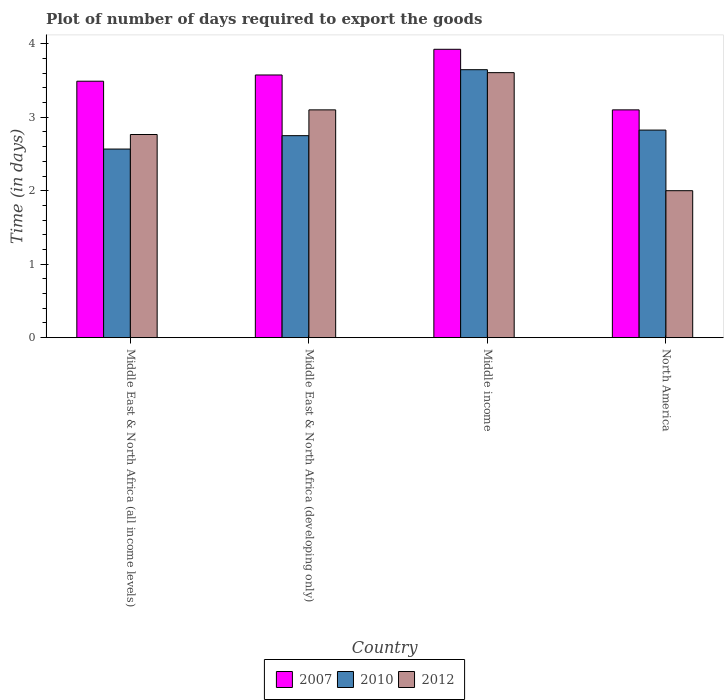Are the number of bars per tick equal to the number of legend labels?
Ensure brevity in your answer.  Yes. Are the number of bars on each tick of the X-axis equal?
Make the answer very short. Yes. How many bars are there on the 1st tick from the left?
Offer a terse response. 3. How many bars are there on the 2nd tick from the right?
Give a very brief answer. 3. What is the label of the 1st group of bars from the left?
Offer a terse response. Middle East & North Africa (all income levels). What is the time required to export goods in 2010 in Middle East & North Africa (all income levels)?
Your answer should be compact. 2.57. Across all countries, what is the maximum time required to export goods in 2012?
Offer a terse response. 3.61. Across all countries, what is the minimum time required to export goods in 2010?
Your response must be concise. 2.57. In which country was the time required to export goods in 2010 minimum?
Your response must be concise. Middle East & North Africa (all income levels). What is the total time required to export goods in 2012 in the graph?
Give a very brief answer. 11.47. What is the difference between the time required to export goods in 2012 in Middle East & North Africa (all income levels) and that in North America?
Your response must be concise. 0.76. What is the difference between the time required to export goods in 2012 in North America and the time required to export goods in 2007 in Middle East & North Africa (developing only)?
Make the answer very short. -1.58. What is the average time required to export goods in 2010 per country?
Your answer should be very brief. 2.95. What is the difference between the time required to export goods of/in 2007 and time required to export goods of/in 2012 in Middle East & North Africa (all income levels)?
Keep it short and to the point. 0.73. What is the ratio of the time required to export goods in 2007 in Middle East & North Africa (developing only) to that in Middle income?
Give a very brief answer. 0.91. Is the time required to export goods in 2010 in Middle income less than that in North America?
Provide a succinct answer. No. What is the difference between the highest and the second highest time required to export goods in 2007?
Provide a short and direct response. -0.35. What is the difference between the highest and the lowest time required to export goods in 2012?
Your answer should be very brief. 1.61. Is it the case that in every country, the sum of the time required to export goods in 2007 and time required to export goods in 2010 is greater than the time required to export goods in 2012?
Offer a terse response. Yes. How many bars are there?
Offer a very short reply. 12. What is the difference between two consecutive major ticks on the Y-axis?
Provide a short and direct response. 1. Does the graph contain grids?
Make the answer very short. No. What is the title of the graph?
Give a very brief answer. Plot of number of days required to export the goods. What is the label or title of the X-axis?
Make the answer very short. Country. What is the label or title of the Y-axis?
Offer a very short reply. Time (in days). What is the Time (in days) in 2007 in Middle East & North Africa (all income levels)?
Give a very brief answer. 3.49. What is the Time (in days) in 2010 in Middle East & North Africa (all income levels)?
Your response must be concise. 2.57. What is the Time (in days) of 2012 in Middle East & North Africa (all income levels)?
Your answer should be very brief. 2.76. What is the Time (in days) in 2007 in Middle East & North Africa (developing only)?
Give a very brief answer. 3.58. What is the Time (in days) of 2010 in Middle East & North Africa (developing only)?
Give a very brief answer. 2.75. What is the Time (in days) of 2012 in Middle East & North Africa (developing only)?
Offer a very short reply. 3.1. What is the Time (in days) in 2007 in Middle income?
Offer a very short reply. 3.92. What is the Time (in days) of 2010 in Middle income?
Make the answer very short. 3.65. What is the Time (in days) in 2012 in Middle income?
Offer a very short reply. 3.61. What is the Time (in days) of 2007 in North America?
Your answer should be compact. 3.1. What is the Time (in days) in 2010 in North America?
Offer a very short reply. 2.83. What is the Time (in days) in 2012 in North America?
Keep it short and to the point. 2. Across all countries, what is the maximum Time (in days) in 2007?
Your response must be concise. 3.92. Across all countries, what is the maximum Time (in days) of 2010?
Offer a very short reply. 3.65. Across all countries, what is the maximum Time (in days) of 2012?
Make the answer very short. 3.61. Across all countries, what is the minimum Time (in days) of 2010?
Offer a terse response. 2.57. What is the total Time (in days) of 2007 in the graph?
Offer a very short reply. 14.09. What is the total Time (in days) of 2010 in the graph?
Provide a short and direct response. 11.79. What is the total Time (in days) in 2012 in the graph?
Provide a succinct answer. 11.47. What is the difference between the Time (in days) of 2007 in Middle East & North Africa (all income levels) and that in Middle East & North Africa (developing only)?
Your response must be concise. -0.09. What is the difference between the Time (in days) of 2010 in Middle East & North Africa (all income levels) and that in Middle East & North Africa (developing only)?
Provide a succinct answer. -0.18. What is the difference between the Time (in days) in 2012 in Middle East & North Africa (all income levels) and that in Middle East & North Africa (developing only)?
Provide a succinct answer. -0.34. What is the difference between the Time (in days) in 2007 in Middle East & North Africa (all income levels) and that in Middle income?
Give a very brief answer. -0.43. What is the difference between the Time (in days) of 2010 in Middle East & North Africa (all income levels) and that in Middle income?
Keep it short and to the point. -1.08. What is the difference between the Time (in days) of 2012 in Middle East & North Africa (all income levels) and that in Middle income?
Offer a terse response. -0.84. What is the difference between the Time (in days) in 2007 in Middle East & North Africa (all income levels) and that in North America?
Provide a succinct answer. 0.39. What is the difference between the Time (in days) in 2010 in Middle East & North Africa (all income levels) and that in North America?
Make the answer very short. -0.26. What is the difference between the Time (in days) in 2012 in Middle East & North Africa (all income levels) and that in North America?
Your answer should be compact. 0.76. What is the difference between the Time (in days) of 2007 in Middle East & North Africa (developing only) and that in Middle income?
Provide a succinct answer. -0.35. What is the difference between the Time (in days) in 2010 in Middle East & North Africa (developing only) and that in Middle income?
Provide a succinct answer. -0.9. What is the difference between the Time (in days) in 2012 in Middle East & North Africa (developing only) and that in Middle income?
Provide a short and direct response. -0.51. What is the difference between the Time (in days) of 2007 in Middle East & North Africa (developing only) and that in North America?
Provide a succinct answer. 0.47. What is the difference between the Time (in days) in 2010 in Middle East & North Africa (developing only) and that in North America?
Your answer should be very brief. -0.08. What is the difference between the Time (in days) in 2007 in Middle income and that in North America?
Offer a very short reply. 0.82. What is the difference between the Time (in days) of 2010 in Middle income and that in North America?
Your response must be concise. 0.82. What is the difference between the Time (in days) of 2012 in Middle income and that in North America?
Offer a very short reply. 1.61. What is the difference between the Time (in days) of 2007 in Middle East & North Africa (all income levels) and the Time (in days) of 2010 in Middle East & North Africa (developing only)?
Your answer should be very brief. 0.74. What is the difference between the Time (in days) of 2007 in Middle East & North Africa (all income levels) and the Time (in days) of 2012 in Middle East & North Africa (developing only)?
Your answer should be compact. 0.39. What is the difference between the Time (in days) in 2010 in Middle East & North Africa (all income levels) and the Time (in days) in 2012 in Middle East & North Africa (developing only)?
Keep it short and to the point. -0.53. What is the difference between the Time (in days) in 2007 in Middle East & North Africa (all income levels) and the Time (in days) in 2010 in Middle income?
Offer a terse response. -0.16. What is the difference between the Time (in days) in 2007 in Middle East & North Africa (all income levels) and the Time (in days) in 2012 in Middle income?
Provide a short and direct response. -0.12. What is the difference between the Time (in days) of 2010 in Middle East & North Africa (all income levels) and the Time (in days) of 2012 in Middle income?
Offer a terse response. -1.04. What is the difference between the Time (in days) of 2007 in Middle East & North Africa (all income levels) and the Time (in days) of 2010 in North America?
Offer a very short reply. 0.67. What is the difference between the Time (in days) in 2007 in Middle East & North Africa (all income levels) and the Time (in days) in 2012 in North America?
Provide a short and direct response. 1.49. What is the difference between the Time (in days) in 2010 in Middle East & North Africa (all income levels) and the Time (in days) in 2012 in North America?
Offer a terse response. 0.57. What is the difference between the Time (in days) in 2007 in Middle East & North Africa (developing only) and the Time (in days) in 2010 in Middle income?
Give a very brief answer. -0.07. What is the difference between the Time (in days) in 2007 in Middle East & North Africa (developing only) and the Time (in days) in 2012 in Middle income?
Your answer should be compact. -0.03. What is the difference between the Time (in days) in 2010 in Middle East & North Africa (developing only) and the Time (in days) in 2012 in Middle income?
Provide a succinct answer. -0.86. What is the difference between the Time (in days) in 2007 in Middle East & North Africa (developing only) and the Time (in days) in 2010 in North America?
Keep it short and to the point. 0.75. What is the difference between the Time (in days) in 2007 in Middle East & North Africa (developing only) and the Time (in days) in 2012 in North America?
Keep it short and to the point. 1.57. What is the difference between the Time (in days) of 2010 in Middle East & North Africa (developing only) and the Time (in days) of 2012 in North America?
Provide a succinct answer. 0.75. What is the difference between the Time (in days) in 2007 in Middle income and the Time (in days) in 2010 in North America?
Offer a terse response. 1.1. What is the difference between the Time (in days) of 2007 in Middle income and the Time (in days) of 2012 in North America?
Your answer should be very brief. 1.92. What is the difference between the Time (in days) of 2010 in Middle income and the Time (in days) of 2012 in North America?
Your answer should be compact. 1.65. What is the average Time (in days) in 2007 per country?
Offer a terse response. 3.52. What is the average Time (in days) of 2010 per country?
Your answer should be very brief. 2.95. What is the average Time (in days) in 2012 per country?
Your response must be concise. 2.87. What is the difference between the Time (in days) in 2007 and Time (in days) in 2010 in Middle East & North Africa (all income levels)?
Give a very brief answer. 0.92. What is the difference between the Time (in days) of 2007 and Time (in days) of 2012 in Middle East & North Africa (all income levels)?
Offer a terse response. 0.73. What is the difference between the Time (in days) in 2010 and Time (in days) in 2012 in Middle East & North Africa (all income levels)?
Provide a short and direct response. -0.2. What is the difference between the Time (in days) in 2007 and Time (in days) in 2010 in Middle East & North Africa (developing only)?
Your response must be concise. 0.83. What is the difference between the Time (in days) of 2007 and Time (in days) of 2012 in Middle East & North Africa (developing only)?
Give a very brief answer. 0.47. What is the difference between the Time (in days) in 2010 and Time (in days) in 2012 in Middle East & North Africa (developing only)?
Provide a short and direct response. -0.35. What is the difference between the Time (in days) in 2007 and Time (in days) in 2010 in Middle income?
Provide a succinct answer. 0.28. What is the difference between the Time (in days) in 2007 and Time (in days) in 2012 in Middle income?
Your answer should be compact. 0.32. What is the difference between the Time (in days) in 2010 and Time (in days) in 2012 in Middle income?
Provide a succinct answer. 0.04. What is the difference between the Time (in days) of 2007 and Time (in days) of 2010 in North America?
Keep it short and to the point. 0.28. What is the difference between the Time (in days) in 2010 and Time (in days) in 2012 in North America?
Ensure brevity in your answer.  0.82. What is the ratio of the Time (in days) in 2007 in Middle East & North Africa (all income levels) to that in Middle East & North Africa (developing only)?
Offer a very short reply. 0.98. What is the ratio of the Time (in days) in 2010 in Middle East & North Africa (all income levels) to that in Middle East & North Africa (developing only)?
Provide a succinct answer. 0.93. What is the ratio of the Time (in days) in 2012 in Middle East & North Africa (all income levels) to that in Middle East & North Africa (developing only)?
Offer a very short reply. 0.89. What is the ratio of the Time (in days) of 2007 in Middle East & North Africa (all income levels) to that in Middle income?
Provide a succinct answer. 0.89. What is the ratio of the Time (in days) in 2010 in Middle East & North Africa (all income levels) to that in Middle income?
Your answer should be very brief. 0.7. What is the ratio of the Time (in days) of 2012 in Middle East & North Africa (all income levels) to that in Middle income?
Give a very brief answer. 0.77. What is the ratio of the Time (in days) in 2007 in Middle East & North Africa (all income levels) to that in North America?
Your answer should be compact. 1.13. What is the ratio of the Time (in days) in 2010 in Middle East & North Africa (all income levels) to that in North America?
Your answer should be very brief. 0.91. What is the ratio of the Time (in days) in 2012 in Middle East & North Africa (all income levels) to that in North America?
Your response must be concise. 1.38. What is the ratio of the Time (in days) in 2007 in Middle East & North Africa (developing only) to that in Middle income?
Provide a short and direct response. 0.91. What is the ratio of the Time (in days) of 2010 in Middle East & North Africa (developing only) to that in Middle income?
Ensure brevity in your answer.  0.75. What is the ratio of the Time (in days) in 2012 in Middle East & North Africa (developing only) to that in Middle income?
Provide a short and direct response. 0.86. What is the ratio of the Time (in days) of 2007 in Middle East & North Africa (developing only) to that in North America?
Your answer should be compact. 1.15. What is the ratio of the Time (in days) in 2010 in Middle East & North Africa (developing only) to that in North America?
Keep it short and to the point. 0.97. What is the ratio of the Time (in days) in 2012 in Middle East & North Africa (developing only) to that in North America?
Ensure brevity in your answer.  1.55. What is the ratio of the Time (in days) in 2007 in Middle income to that in North America?
Your answer should be very brief. 1.27. What is the ratio of the Time (in days) in 2010 in Middle income to that in North America?
Provide a succinct answer. 1.29. What is the ratio of the Time (in days) in 2012 in Middle income to that in North America?
Offer a terse response. 1.8. What is the difference between the highest and the second highest Time (in days) in 2007?
Your response must be concise. 0.35. What is the difference between the highest and the second highest Time (in days) in 2010?
Make the answer very short. 0.82. What is the difference between the highest and the second highest Time (in days) in 2012?
Keep it short and to the point. 0.51. What is the difference between the highest and the lowest Time (in days) of 2007?
Provide a succinct answer. 0.82. What is the difference between the highest and the lowest Time (in days) of 2012?
Your answer should be very brief. 1.61. 